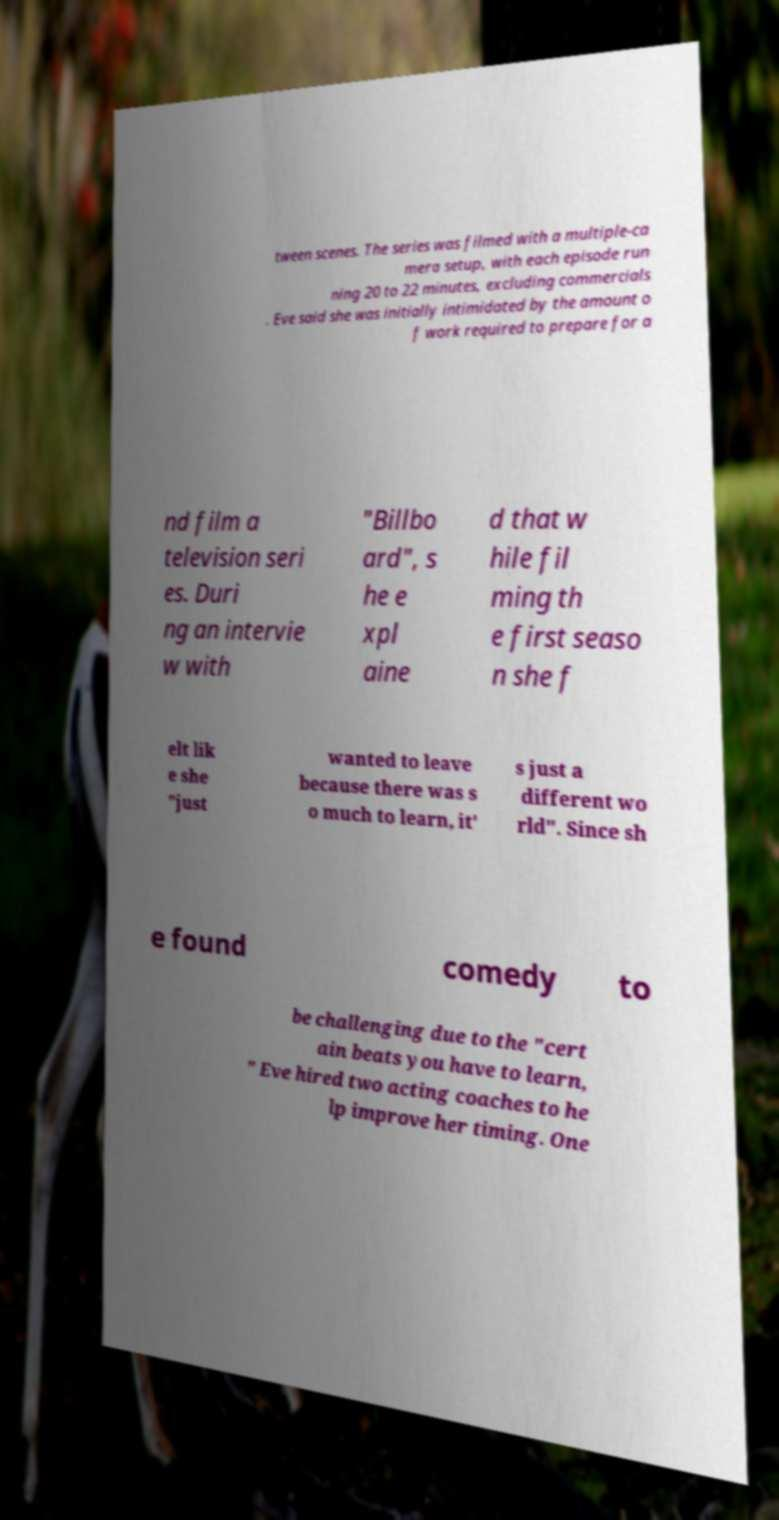Could you extract and type out the text from this image? tween scenes. The series was filmed with a multiple-ca mera setup, with each episode run ning 20 to 22 minutes, excluding commercials . Eve said she was initially intimidated by the amount o f work required to prepare for a nd film a television seri es. Duri ng an intervie w with "Billbo ard", s he e xpl aine d that w hile fil ming th e first seaso n she f elt lik e she "just wanted to leave because there was s o much to learn, it' s just a different wo rld". Since sh e found comedy to be challenging due to the "cert ain beats you have to learn, " Eve hired two acting coaches to he lp improve her timing. One 